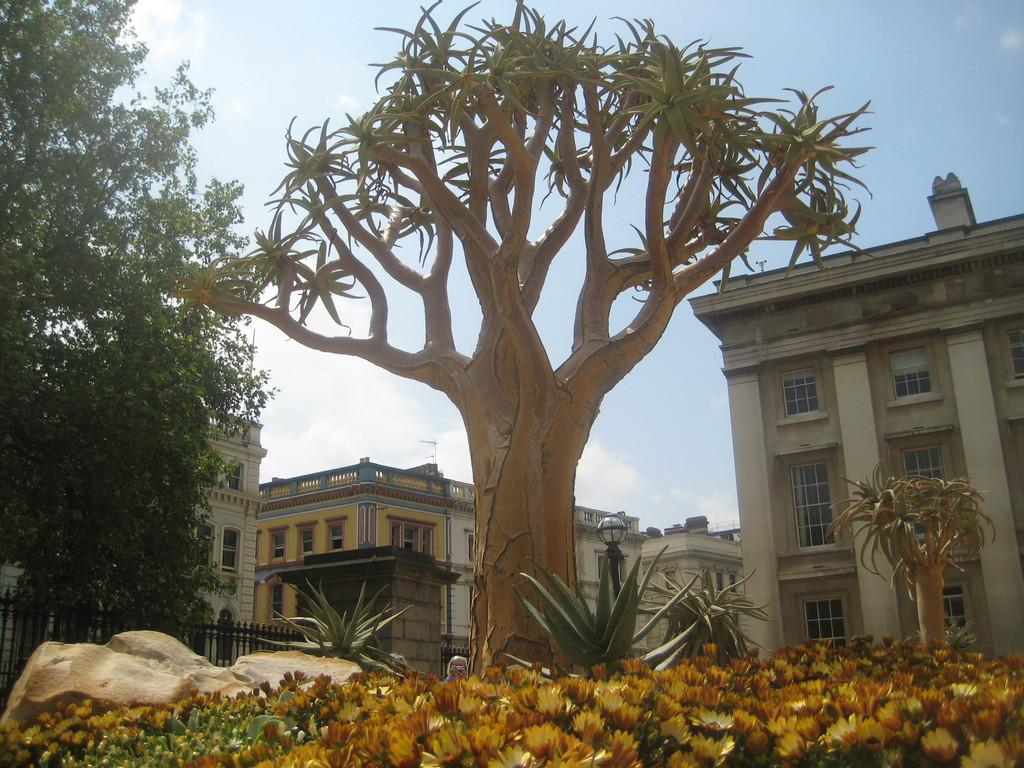What type of structures are present in the image? There are buildings in the image. Where can trees be found in the image? Trees can be found on both the left and right sides of the image. What other natural elements are visible in the image? Flowers are visible at the bottom of the image. What part of the natural environment is visible in the image? The sky is visible at the top of the image. What type of flowers are hanging from the flag in the image? There is no flag present in the image, so there are no flowers hanging from a flag. 